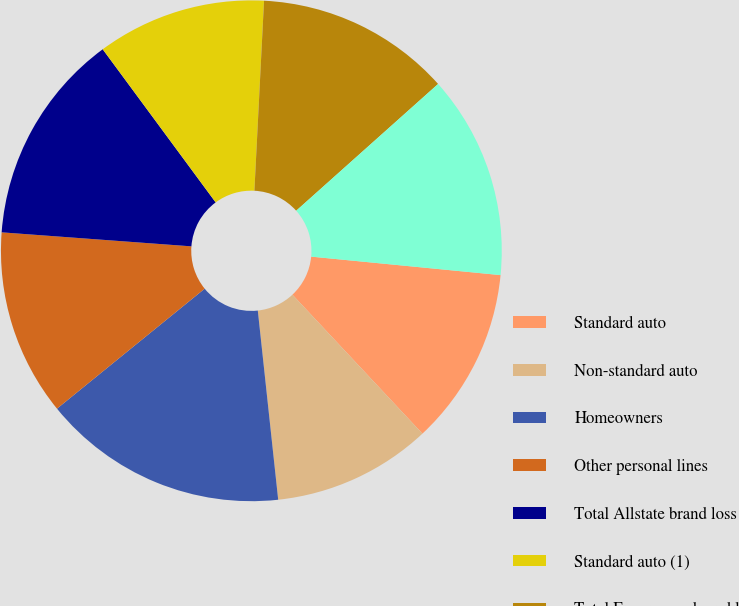Convert chart to OTSL. <chart><loc_0><loc_0><loc_500><loc_500><pie_chart><fcel>Standard auto<fcel>Non-standard auto<fcel>Homeowners<fcel>Other personal lines<fcel>Total Allstate brand loss<fcel>Standard auto (1)<fcel>Total Encompass brand loss<fcel>Allstate Protection loss ratio<nl><fcel>11.48%<fcel>10.26%<fcel>15.85%<fcel>12.03%<fcel>13.71%<fcel>10.92%<fcel>12.59%<fcel>13.15%<nl></chart> 